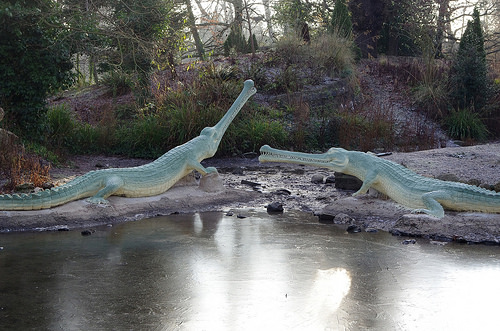<image>
Is the water to the right of the crocodile? No. The water is not to the right of the crocodile. The horizontal positioning shows a different relationship. 